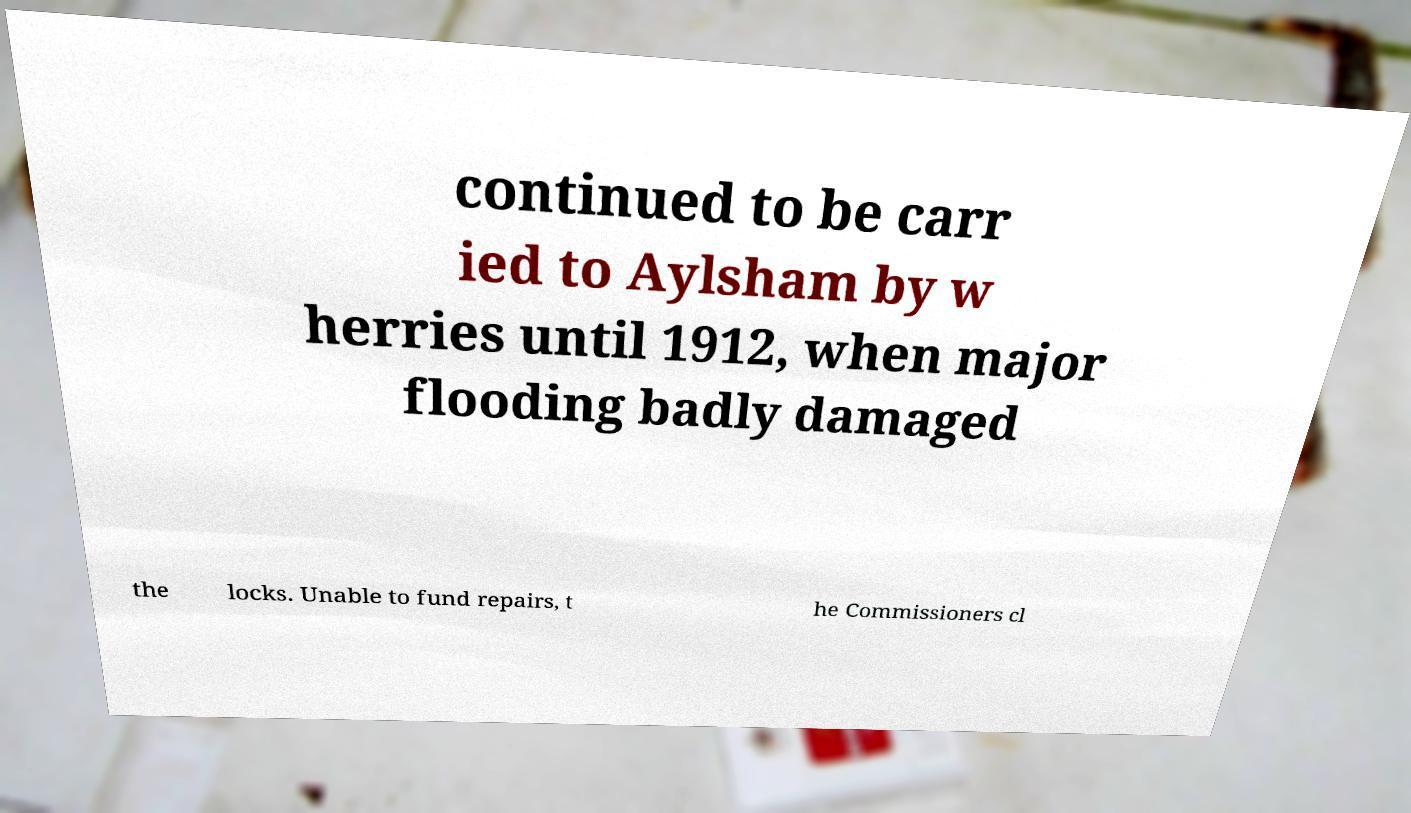What messages or text are displayed in this image? I need them in a readable, typed format. continued to be carr ied to Aylsham by w herries until 1912, when major flooding badly damaged the locks. Unable to fund repairs, t he Commissioners cl 